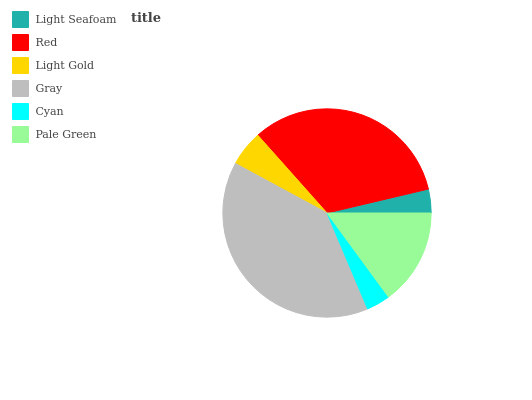Is Cyan the minimum?
Answer yes or no. Yes. Is Gray the maximum?
Answer yes or no. Yes. Is Red the minimum?
Answer yes or no. No. Is Red the maximum?
Answer yes or no. No. Is Red greater than Light Seafoam?
Answer yes or no. Yes. Is Light Seafoam less than Red?
Answer yes or no. Yes. Is Light Seafoam greater than Red?
Answer yes or no. No. Is Red less than Light Seafoam?
Answer yes or no. No. Is Pale Green the high median?
Answer yes or no. Yes. Is Light Gold the low median?
Answer yes or no. Yes. Is Light Seafoam the high median?
Answer yes or no. No. Is Red the low median?
Answer yes or no. No. 